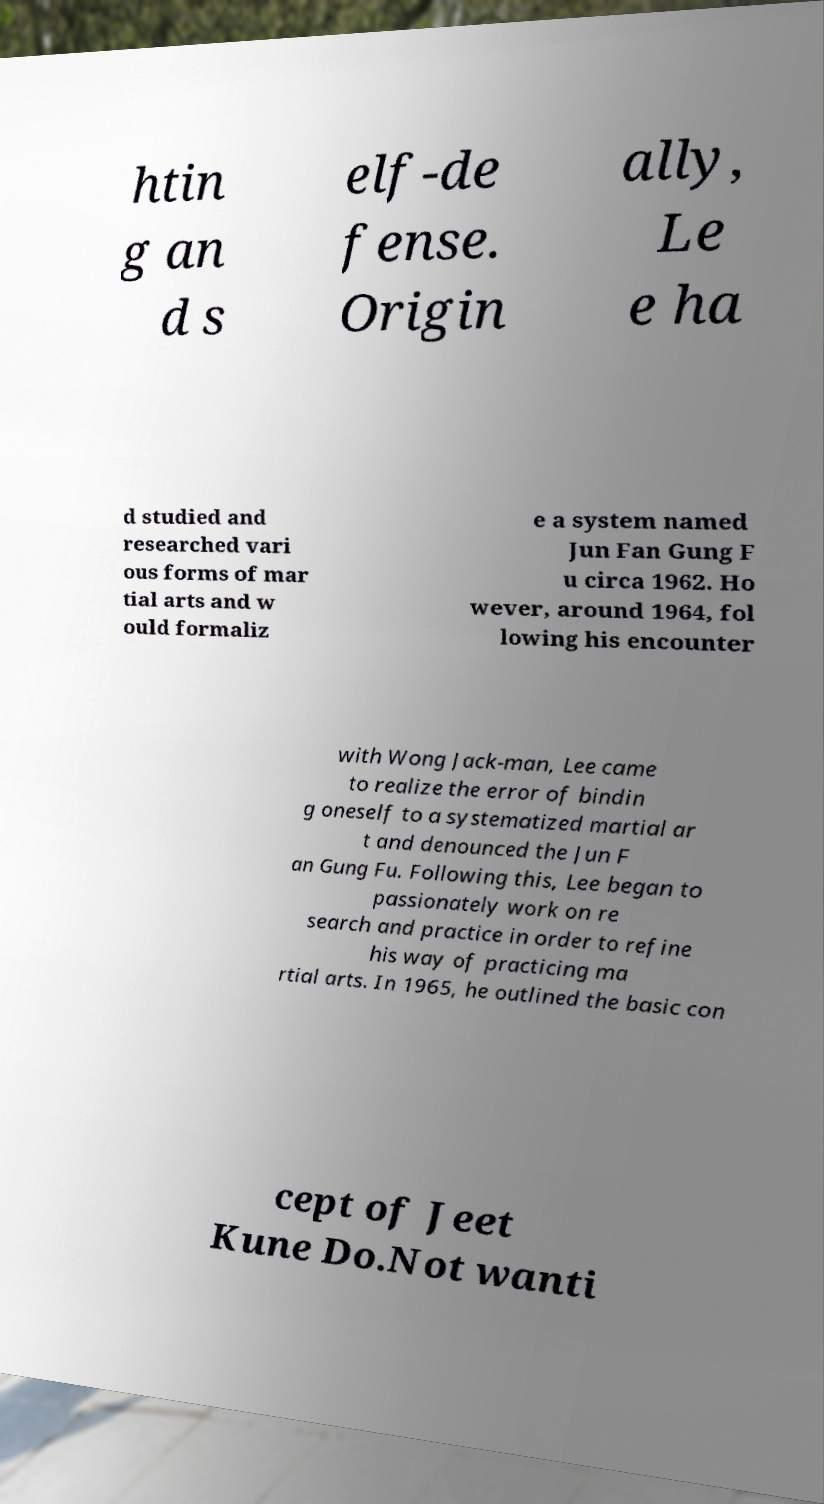Please identify and transcribe the text found in this image. htin g an d s elf-de fense. Origin ally, Le e ha d studied and researched vari ous forms of mar tial arts and w ould formaliz e a system named Jun Fan Gung F u circa 1962. Ho wever, around 1964, fol lowing his encounter with Wong Jack-man, Lee came to realize the error of bindin g oneself to a systematized martial ar t and denounced the Jun F an Gung Fu. Following this, Lee began to passionately work on re search and practice in order to refine his way of practicing ma rtial arts. In 1965, he outlined the basic con cept of Jeet Kune Do.Not wanti 